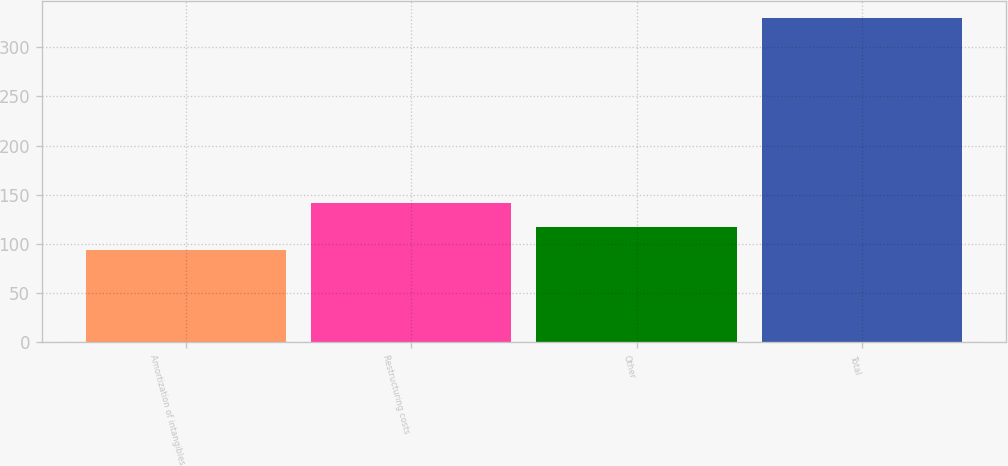Convert chart. <chart><loc_0><loc_0><loc_500><loc_500><bar_chart><fcel>Amortization of intangibles<fcel>Restructuring costs<fcel>Other<fcel>Total<nl><fcel>94<fcel>141.2<fcel>117.6<fcel>330<nl></chart> 